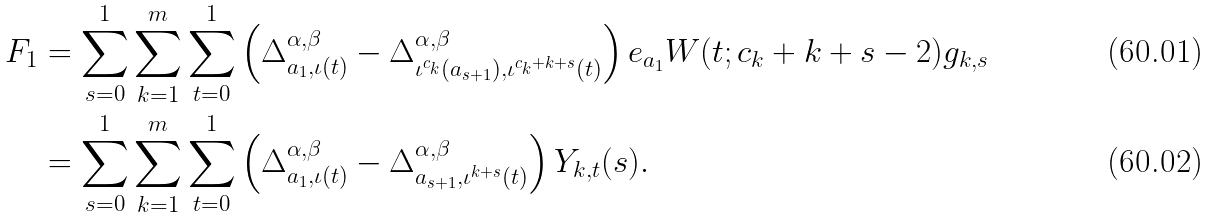<formula> <loc_0><loc_0><loc_500><loc_500>F _ { 1 } & = \sum _ { s = 0 } ^ { 1 } \sum _ { k = 1 } ^ { m } \sum _ { t = 0 } ^ { 1 } \left ( \Delta _ { a _ { 1 } , \iota ( t ) } ^ { \alpha , \beta } - \Delta _ { \iota ^ { c _ { k } } ( a _ { s + 1 } ) , \iota ^ { c _ { k } + k + s } ( t ) } ^ { \alpha , \beta } \right ) e _ { a _ { 1 } } W ( t ; c _ { k } + k + s - 2 ) g _ { k , s } \\ & = \sum _ { s = 0 } ^ { 1 } \sum _ { k = 1 } ^ { m } \sum _ { t = 0 } ^ { 1 } \left ( \Delta _ { a _ { 1 } , \iota ( t ) } ^ { \alpha , \beta } - \Delta _ { a _ { s + 1 } , \iota ^ { k + s } ( t ) } ^ { \alpha , \beta } \right ) Y _ { k , t } ( s ) .</formula> 